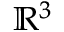<formula> <loc_0><loc_0><loc_500><loc_500>\mathbb { R } ^ { 3 }</formula> 